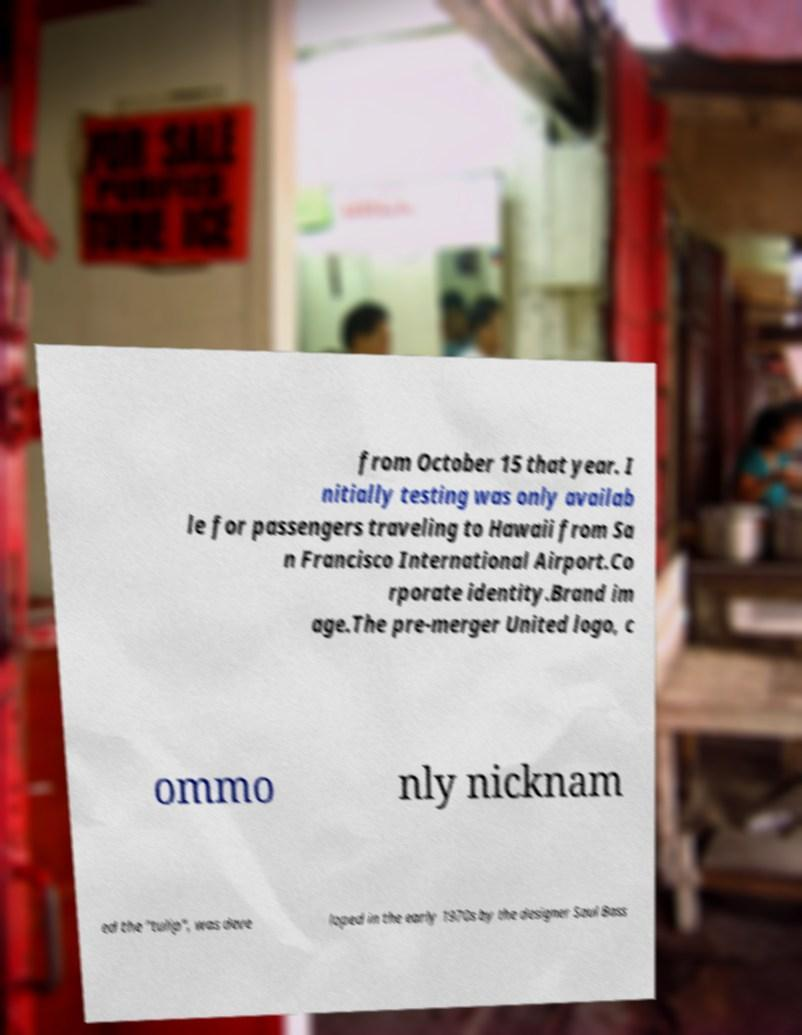What messages or text are displayed in this image? I need them in a readable, typed format. from October 15 that year. I nitially testing was only availab le for passengers traveling to Hawaii from Sa n Francisco International Airport.Co rporate identity.Brand im age.The pre-merger United logo, c ommo nly nicknam ed the "tulip", was deve loped in the early 1970s by the designer Saul Bass 